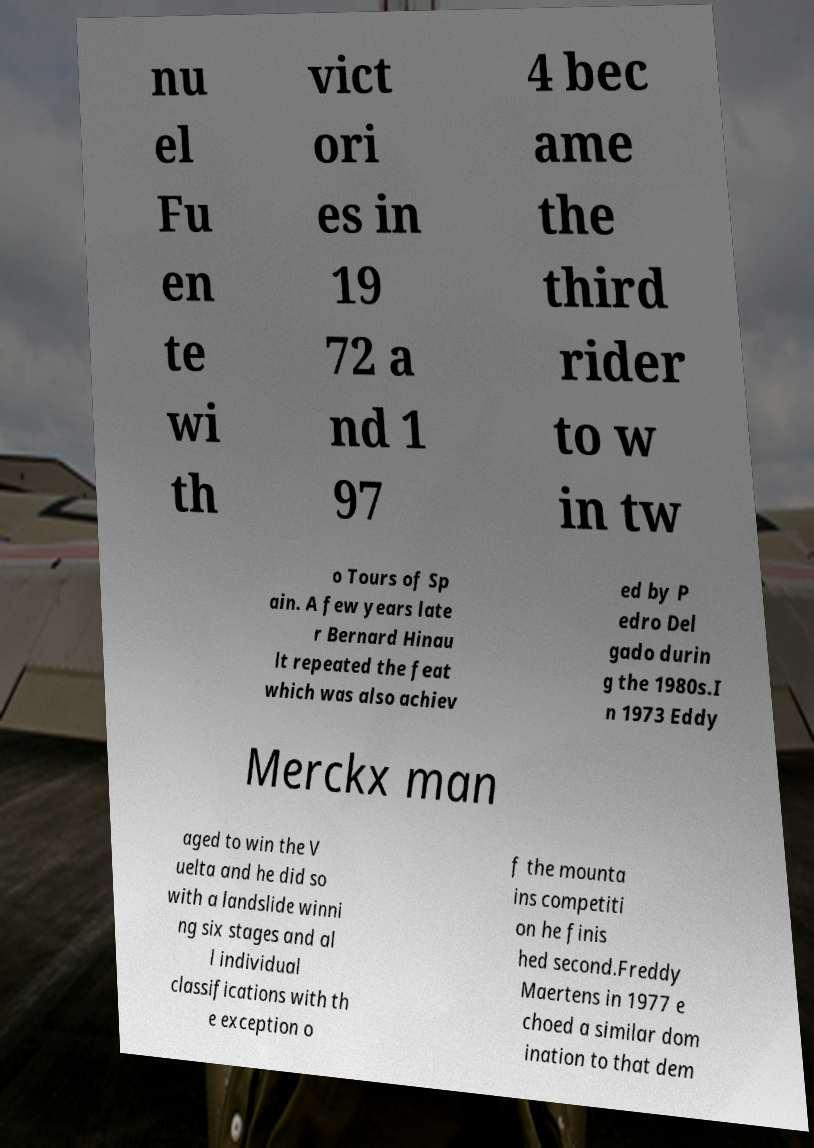For documentation purposes, I need the text within this image transcribed. Could you provide that? nu el Fu en te wi th vict ori es in 19 72 a nd 1 97 4 bec ame the third rider to w in tw o Tours of Sp ain. A few years late r Bernard Hinau lt repeated the feat which was also achiev ed by P edro Del gado durin g the 1980s.I n 1973 Eddy Merckx man aged to win the V uelta and he did so with a landslide winni ng six stages and al l individual classifications with th e exception o f the mounta ins competiti on he finis hed second.Freddy Maertens in 1977 e choed a similar dom ination to that dem 